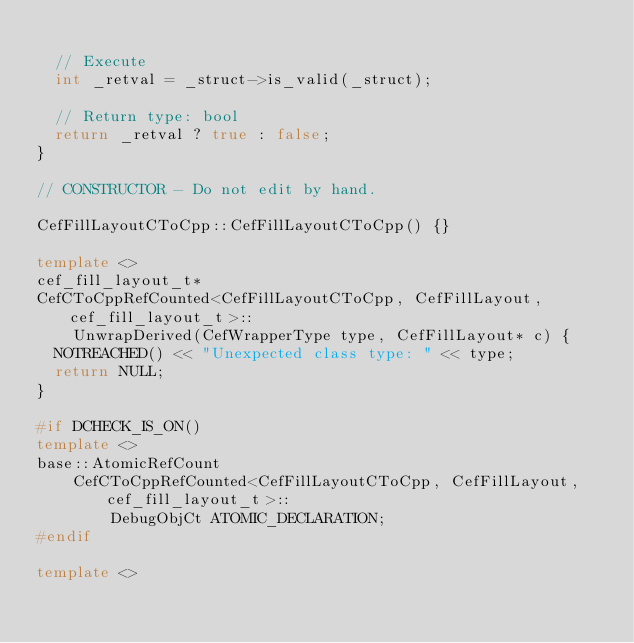<code> <loc_0><loc_0><loc_500><loc_500><_C++_>
  // Execute
  int _retval = _struct->is_valid(_struct);

  // Return type: bool
  return _retval ? true : false;
}

// CONSTRUCTOR - Do not edit by hand.

CefFillLayoutCToCpp::CefFillLayoutCToCpp() {}

template <>
cef_fill_layout_t*
CefCToCppRefCounted<CefFillLayoutCToCpp, CefFillLayout, cef_fill_layout_t>::
    UnwrapDerived(CefWrapperType type, CefFillLayout* c) {
  NOTREACHED() << "Unexpected class type: " << type;
  return NULL;
}

#if DCHECK_IS_ON()
template <>
base::AtomicRefCount
    CefCToCppRefCounted<CefFillLayoutCToCpp, CefFillLayout, cef_fill_layout_t>::
        DebugObjCt ATOMIC_DECLARATION;
#endif

template <></code> 